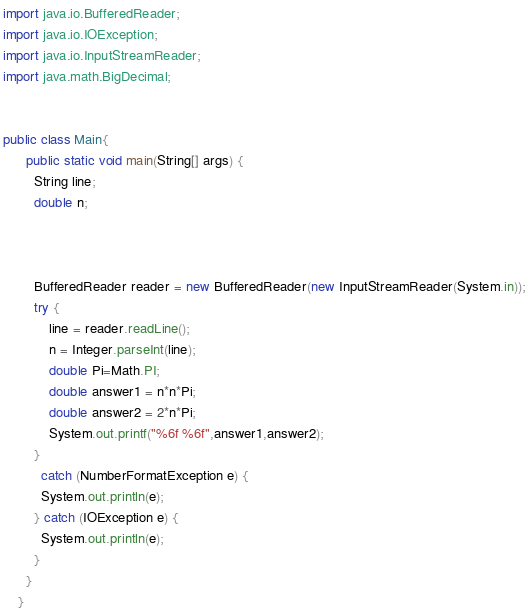<code> <loc_0><loc_0><loc_500><loc_500><_Java_>import java.io.BufferedReader;
import java.io.IOException;
import java.io.InputStreamReader;
import java.math.BigDecimal;


public class Main{
	  public static void main(String[] args) {
	    String line;
	    double n;

	  

	    BufferedReader reader = new BufferedReader(new InputStreamReader(System.in));
	    try {
	        line = reader.readLine();
	        n = Integer.parseInt(line);
	        double Pi=Math.PI;
	        double answer1 = n*n*Pi;
	        double answer2 = 2*n*Pi;
	        System.out.printf("%6f %6f",answer1,answer2);
	    }
	      catch (NumberFormatException e) {
	      System.out.println(e);
	    } catch (IOException e) {
	      System.out.println(e);
	    }
	  }
	}</code> 